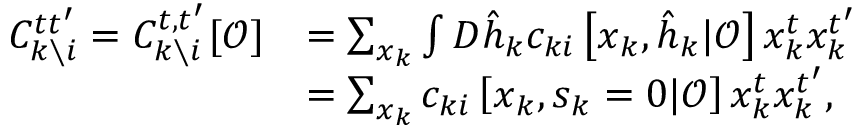Convert formula to latex. <formula><loc_0><loc_0><loc_500><loc_500>\begin{array} { r l } { C _ { k \ i } ^ { t t ^ { \prime } } = C _ { k \ i } ^ { t , t ^ { \prime } } [ \mathcal { O } ] } & { = \sum _ { x _ { k } } \int D \hat { h } _ { k } c _ { k i } \left [ x _ { k } , \hat { h } _ { k } | \mathcal { O } \right ] x _ { k } ^ { t } x _ { k } ^ { t ^ { \prime } } } \\ & { = \sum _ { x _ { k } } c _ { k i } \left [ x _ { k } , s _ { k } = 0 | \mathcal { O } \right ] x _ { k } ^ { t } x _ { k } ^ { t ^ { \prime } } , } \end{array}</formula> 